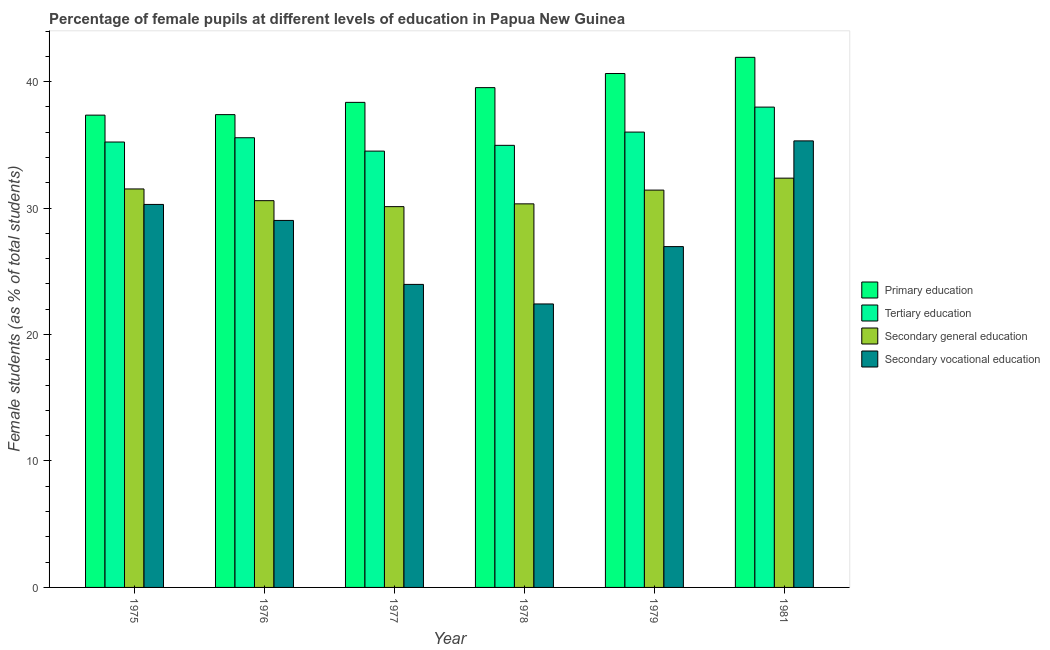How many different coloured bars are there?
Your answer should be very brief. 4. How many groups of bars are there?
Offer a terse response. 6. Are the number of bars per tick equal to the number of legend labels?
Your answer should be very brief. Yes. How many bars are there on the 4th tick from the left?
Offer a very short reply. 4. What is the label of the 1st group of bars from the left?
Give a very brief answer. 1975. In how many cases, is the number of bars for a given year not equal to the number of legend labels?
Your answer should be compact. 0. What is the percentage of female students in secondary vocational education in 1977?
Your response must be concise. 23.97. Across all years, what is the maximum percentage of female students in primary education?
Give a very brief answer. 41.92. Across all years, what is the minimum percentage of female students in primary education?
Ensure brevity in your answer.  37.35. In which year was the percentage of female students in primary education minimum?
Make the answer very short. 1975. What is the total percentage of female students in secondary vocational education in the graph?
Your response must be concise. 167.96. What is the difference between the percentage of female students in secondary vocational education in 1978 and that in 1979?
Give a very brief answer. -4.53. What is the difference between the percentage of female students in tertiary education in 1979 and the percentage of female students in secondary vocational education in 1981?
Your response must be concise. -1.98. What is the average percentage of female students in secondary education per year?
Provide a short and direct response. 31.06. What is the ratio of the percentage of female students in secondary vocational education in 1978 to that in 1981?
Offer a very short reply. 0.63. What is the difference between the highest and the second highest percentage of female students in primary education?
Offer a terse response. 1.28. What is the difference between the highest and the lowest percentage of female students in secondary vocational education?
Your response must be concise. 12.9. In how many years, is the percentage of female students in secondary education greater than the average percentage of female students in secondary education taken over all years?
Your answer should be compact. 3. Is the sum of the percentage of female students in secondary education in 1976 and 1979 greater than the maximum percentage of female students in tertiary education across all years?
Your response must be concise. Yes. What does the 1st bar from the left in 1981 represents?
Offer a terse response. Primary education. What does the 1st bar from the right in 1975 represents?
Make the answer very short. Secondary vocational education. Is it the case that in every year, the sum of the percentage of female students in primary education and percentage of female students in tertiary education is greater than the percentage of female students in secondary education?
Keep it short and to the point. Yes. How many bars are there?
Your answer should be very brief. 24. How many years are there in the graph?
Your answer should be compact. 6. Does the graph contain any zero values?
Give a very brief answer. No. How are the legend labels stacked?
Your response must be concise. Vertical. What is the title of the graph?
Give a very brief answer. Percentage of female pupils at different levels of education in Papua New Guinea. Does "UNPBF" appear as one of the legend labels in the graph?
Give a very brief answer. No. What is the label or title of the Y-axis?
Offer a very short reply. Female students (as % of total students). What is the Female students (as % of total students) of Primary education in 1975?
Your answer should be compact. 37.35. What is the Female students (as % of total students) in Tertiary education in 1975?
Provide a short and direct response. 35.22. What is the Female students (as % of total students) in Secondary general education in 1975?
Ensure brevity in your answer.  31.51. What is the Female students (as % of total students) in Secondary vocational education in 1975?
Keep it short and to the point. 30.29. What is the Female students (as % of total students) in Primary education in 1976?
Your answer should be very brief. 37.39. What is the Female students (as % of total students) of Tertiary education in 1976?
Give a very brief answer. 35.56. What is the Female students (as % of total students) in Secondary general education in 1976?
Your answer should be compact. 30.59. What is the Female students (as % of total students) in Secondary vocational education in 1976?
Your answer should be very brief. 29.02. What is the Female students (as % of total students) in Primary education in 1977?
Ensure brevity in your answer.  38.36. What is the Female students (as % of total students) in Tertiary education in 1977?
Your answer should be compact. 34.51. What is the Female students (as % of total students) in Secondary general education in 1977?
Offer a terse response. 30.11. What is the Female students (as % of total students) of Secondary vocational education in 1977?
Your response must be concise. 23.97. What is the Female students (as % of total students) in Primary education in 1978?
Your response must be concise. 39.53. What is the Female students (as % of total students) in Tertiary education in 1978?
Provide a succinct answer. 34.96. What is the Female students (as % of total students) of Secondary general education in 1978?
Ensure brevity in your answer.  30.33. What is the Female students (as % of total students) in Secondary vocational education in 1978?
Your answer should be compact. 22.42. What is the Female students (as % of total students) of Primary education in 1979?
Ensure brevity in your answer.  40.64. What is the Female students (as % of total students) in Tertiary education in 1979?
Keep it short and to the point. 36.01. What is the Female students (as % of total students) in Secondary general education in 1979?
Your answer should be very brief. 31.42. What is the Female students (as % of total students) in Secondary vocational education in 1979?
Keep it short and to the point. 26.95. What is the Female students (as % of total students) of Primary education in 1981?
Offer a very short reply. 41.92. What is the Female students (as % of total students) of Tertiary education in 1981?
Your answer should be compact. 37.99. What is the Female students (as % of total students) of Secondary general education in 1981?
Your answer should be very brief. 32.37. What is the Female students (as % of total students) of Secondary vocational education in 1981?
Your answer should be very brief. 35.31. Across all years, what is the maximum Female students (as % of total students) in Primary education?
Give a very brief answer. 41.92. Across all years, what is the maximum Female students (as % of total students) in Tertiary education?
Offer a very short reply. 37.99. Across all years, what is the maximum Female students (as % of total students) in Secondary general education?
Ensure brevity in your answer.  32.37. Across all years, what is the maximum Female students (as % of total students) of Secondary vocational education?
Your answer should be very brief. 35.31. Across all years, what is the minimum Female students (as % of total students) in Primary education?
Offer a very short reply. 37.35. Across all years, what is the minimum Female students (as % of total students) in Tertiary education?
Give a very brief answer. 34.51. Across all years, what is the minimum Female students (as % of total students) in Secondary general education?
Offer a very short reply. 30.11. Across all years, what is the minimum Female students (as % of total students) of Secondary vocational education?
Provide a succinct answer. 22.42. What is the total Female students (as % of total students) of Primary education in the graph?
Give a very brief answer. 235.19. What is the total Female students (as % of total students) in Tertiary education in the graph?
Your response must be concise. 214.25. What is the total Female students (as % of total students) of Secondary general education in the graph?
Your answer should be very brief. 186.34. What is the total Female students (as % of total students) of Secondary vocational education in the graph?
Ensure brevity in your answer.  167.96. What is the difference between the Female students (as % of total students) in Primary education in 1975 and that in 1976?
Give a very brief answer. -0.04. What is the difference between the Female students (as % of total students) in Tertiary education in 1975 and that in 1976?
Provide a short and direct response. -0.34. What is the difference between the Female students (as % of total students) of Secondary general education in 1975 and that in 1976?
Your response must be concise. 0.93. What is the difference between the Female students (as % of total students) of Secondary vocational education in 1975 and that in 1976?
Offer a very short reply. 1.27. What is the difference between the Female students (as % of total students) of Primary education in 1975 and that in 1977?
Offer a very short reply. -1.01. What is the difference between the Female students (as % of total students) of Tertiary education in 1975 and that in 1977?
Make the answer very short. 0.72. What is the difference between the Female students (as % of total students) in Secondary general education in 1975 and that in 1977?
Offer a very short reply. 1.4. What is the difference between the Female students (as % of total students) in Secondary vocational education in 1975 and that in 1977?
Provide a short and direct response. 6.32. What is the difference between the Female students (as % of total students) of Primary education in 1975 and that in 1978?
Ensure brevity in your answer.  -2.17. What is the difference between the Female students (as % of total students) of Tertiary education in 1975 and that in 1978?
Provide a short and direct response. 0.26. What is the difference between the Female students (as % of total students) in Secondary general education in 1975 and that in 1978?
Ensure brevity in your answer.  1.18. What is the difference between the Female students (as % of total students) of Secondary vocational education in 1975 and that in 1978?
Your response must be concise. 7.87. What is the difference between the Female students (as % of total students) of Primary education in 1975 and that in 1979?
Ensure brevity in your answer.  -3.29. What is the difference between the Female students (as % of total students) of Tertiary education in 1975 and that in 1979?
Keep it short and to the point. -0.79. What is the difference between the Female students (as % of total students) of Secondary general education in 1975 and that in 1979?
Offer a very short reply. 0.09. What is the difference between the Female students (as % of total students) of Secondary vocational education in 1975 and that in 1979?
Offer a terse response. 3.34. What is the difference between the Female students (as % of total students) of Primary education in 1975 and that in 1981?
Offer a terse response. -4.57. What is the difference between the Female students (as % of total students) of Tertiary education in 1975 and that in 1981?
Ensure brevity in your answer.  -2.76. What is the difference between the Female students (as % of total students) in Secondary general education in 1975 and that in 1981?
Provide a succinct answer. -0.85. What is the difference between the Female students (as % of total students) of Secondary vocational education in 1975 and that in 1981?
Your answer should be very brief. -5.02. What is the difference between the Female students (as % of total students) in Primary education in 1976 and that in 1977?
Give a very brief answer. -0.97. What is the difference between the Female students (as % of total students) of Tertiary education in 1976 and that in 1977?
Offer a terse response. 1.06. What is the difference between the Female students (as % of total students) of Secondary general education in 1976 and that in 1977?
Offer a terse response. 0.47. What is the difference between the Female students (as % of total students) of Secondary vocational education in 1976 and that in 1977?
Ensure brevity in your answer.  5.06. What is the difference between the Female students (as % of total students) of Primary education in 1976 and that in 1978?
Provide a succinct answer. -2.13. What is the difference between the Female students (as % of total students) in Tertiary education in 1976 and that in 1978?
Provide a succinct answer. 0.6. What is the difference between the Female students (as % of total students) in Secondary general education in 1976 and that in 1978?
Ensure brevity in your answer.  0.25. What is the difference between the Female students (as % of total students) of Secondary vocational education in 1976 and that in 1978?
Make the answer very short. 6.6. What is the difference between the Female students (as % of total students) in Primary education in 1976 and that in 1979?
Your answer should be very brief. -3.25. What is the difference between the Female students (as % of total students) in Tertiary education in 1976 and that in 1979?
Keep it short and to the point. -0.45. What is the difference between the Female students (as % of total students) of Secondary general education in 1976 and that in 1979?
Your response must be concise. -0.84. What is the difference between the Female students (as % of total students) in Secondary vocational education in 1976 and that in 1979?
Offer a terse response. 2.07. What is the difference between the Female students (as % of total students) of Primary education in 1976 and that in 1981?
Your answer should be compact. -4.53. What is the difference between the Female students (as % of total students) in Tertiary education in 1976 and that in 1981?
Your answer should be very brief. -2.42. What is the difference between the Female students (as % of total students) in Secondary general education in 1976 and that in 1981?
Offer a very short reply. -1.78. What is the difference between the Female students (as % of total students) in Secondary vocational education in 1976 and that in 1981?
Provide a short and direct response. -6.29. What is the difference between the Female students (as % of total students) in Primary education in 1977 and that in 1978?
Offer a very short reply. -1.17. What is the difference between the Female students (as % of total students) of Tertiary education in 1977 and that in 1978?
Your response must be concise. -0.46. What is the difference between the Female students (as % of total students) in Secondary general education in 1977 and that in 1978?
Offer a very short reply. -0.22. What is the difference between the Female students (as % of total students) of Secondary vocational education in 1977 and that in 1978?
Keep it short and to the point. 1.55. What is the difference between the Female students (as % of total students) in Primary education in 1977 and that in 1979?
Provide a succinct answer. -2.28. What is the difference between the Female students (as % of total students) in Tertiary education in 1977 and that in 1979?
Offer a terse response. -1.5. What is the difference between the Female students (as % of total students) of Secondary general education in 1977 and that in 1979?
Your answer should be very brief. -1.31. What is the difference between the Female students (as % of total students) of Secondary vocational education in 1977 and that in 1979?
Make the answer very short. -2.99. What is the difference between the Female students (as % of total students) in Primary education in 1977 and that in 1981?
Make the answer very short. -3.56. What is the difference between the Female students (as % of total students) in Tertiary education in 1977 and that in 1981?
Provide a short and direct response. -3.48. What is the difference between the Female students (as % of total students) of Secondary general education in 1977 and that in 1981?
Your response must be concise. -2.25. What is the difference between the Female students (as % of total students) in Secondary vocational education in 1977 and that in 1981?
Keep it short and to the point. -11.35. What is the difference between the Female students (as % of total students) in Primary education in 1978 and that in 1979?
Make the answer very short. -1.12. What is the difference between the Female students (as % of total students) of Tertiary education in 1978 and that in 1979?
Give a very brief answer. -1.05. What is the difference between the Female students (as % of total students) of Secondary general education in 1978 and that in 1979?
Make the answer very short. -1.09. What is the difference between the Female students (as % of total students) in Secondary vocational education in 1978 and that in 1979?
Make the answer very short. -4.53. What is the difference between the Female students (as % of total students) in Primary education in 1978 and that in 1981?
Offer a terse response. -2.4. What is the difference between the Female students (as % of total students) in Tertiary education in 1978 and that in 1981?
Your response must be concise. -3.02. What is the difference between the Female students (as % of total students) of Secondary general education in 1978 and that in 1981?
Provide a short and direct response. -2.03. What is the difference between the Female students (as % of total students) in Secondary vocational education in 1978 and that in 1981?
Provide a succinct answer. -12.9. What is the difference between the Female students (as % of total students) in Primary education in 1979 and that in 1981?
Give a very brief answer. -1.28. What is the difference between the Female students (as % of total students) in Tertiary education in 1979 and that in 1981?
Ensure brevity in your answer.  -1.98. What is the difference between the Female students (as % of total students) in Secondary general education in 1979 and that in 1981?
Provide a succinct answer. -0.95. What is the difference between the Female students (as % of total students) of Secondary vocational education in 1979 and that in 1981?
Give a very brief answer. -8.36. What is the difference between the Female students (as % of total students) in Primary education in 1975 and the Female students (as % of total students) in Tertiary education in 1976?
Make the answer very short. 1.79. What is the difference between the Female students (as % of total students) of Primary education in 1975 and the Female students (as % of total students) of Secondary general education in 1976?
Your answer should be very brief. 6.76. What is the difference between the Female students (as % of total students) of Primary education in 1975 and the Female students (as % of total students) of Secondary vocational education in 1976?
Your answer should be very brief. 8.33. What is the difference between the Female students (as % of total students) of Tertiary education in 1975 and the Female students (as % of total students) of Secondary general education in 1976?
Offer a very short reply. 4.64. What is the difference between the Female students (as % of total students) of Tertiary education in 1975 and the Female students (as % of total students) of Secondary vocational education in 1976?
Your answer should be very brief. 6.2. What is the difference between the Female students (as % of total students) in Secondary general education in 1975 and the Female students (as % of total students) in Secondary vocational education in 1976?
Offer a very short reply. 2.49. What is the difference between the Female students (as % of total students) of Primary education in 1975 and the Female students (as % of total students) of Tertiary education in 1977?
Ensure brevity in your answer.  2.84. What is the difference between the Female students (as % of total students) in Primary education in 1975 and the Female students (as % of total students) in Secondary general education in 1977?
Your response must be concise. 7.24. What is the difference between the Female students (as % of total students) of Primary education in 1975 and the Female students (as % of total students) of Secondary vocational education in 1977?
Provide a short and direct response. 13.39. What is the difference between the Female students (as % of total students) of Tertiary education in 1975 and the Female students (as % of total students) of Secondary general education in 1977?
Provide a short and direct response. 5.11. What is the difference between the Female students (as % of total students) of Tertiary education in 1975 and the Female students (as % of total students) of Secondary vocational education in 1977?
Provide a short and direct response. 11.26. What is the difference between the Female students (as % of total students) in Secondary general education in 1975 and the Female students (as % of total students) in Secondary vocational education in 1977?
Give a very brief answer. 7.55. What is the difference between the Female students (as % of total students) in Primary education in 1975 and the Female students (as % of total students) in Tertiary education in 1978?
Your answer should be very brief. 2.39. What is the difference between the Female students (as % of total students) in Primary education in 1975 and the Female students (as % of total students) in Secondary general education in 1978?
Your response must be concise. 7.02. What is the difference between the Female students (as % of total students) of Primary education in 1975 and the Female students (as % of total students) of Secondary vocational education in 1978?
Offer a very short reply. 14.93. What is the difference between the Female students (as % of total students) of Tertiary education in 1975 and the Female students (as % of total students) of Secondary general education in 1978?
Your answer should be very brief. 4.89. What is the difference between the Female students (as % of total students) of Tertiary education in 1975 and the Female students (as % of total students) of Secondary vocational education in 1978?
Your answer should be very brief. 12.81. What is the difference between the Female students (as % of total students) in Secondary general education in 1975 and the Female students (as % of total students) in Secondary vocational education in 1978?
Provide a succinct answer. 9.1. What is the difference between the Female students (as % of total students) of Primary education in 1975 and the Female students (as % of total students) of Tertiary education in 1979?
Provide a succinct answer. 1.34. What is the difference between the Female students (as % of total students) of Primary education in 1975 and the Female students (as % of total students) of Secondary general education in 1979?
Provide a short and direct response. 5.93. What is the difference between the Female students (as % of total students) of Primary education in 1975 and the Female students (as % of total students) of Secondary vocational education in 1979?
Ensure brevity in your answer.  10.4. What is the difference between the Female students (as % of total students) in Tertiary education in 1975 and the Female students (as % of total students) in Secondary general education in 1979?
Keep it short and to the point. 3.8. What is the difference between the Female students (as % of total students) in Tertiary education in 1975 and the Female students (as % of total students) in Secondary vocational education in 1979?
Provide a succinct answer. 8.27. What is the difference between the Female students (as % of total students) in Secondary general education in 1975 and the Female students (as % of total students) in Secondary vocational education in 1979?
Your answer should be compact. 4.56. What is the difference between the Female students (as % of total students) in Primary education in 1975 and the Female students (as % of total students) in Tertiary education in 1981?
Give a very brief answer. -0.64. What is the difference between the Female students (as % of total students) of Primary education in 1975 and the Female students (as % of total students) of Secondary general education in 1981?
Provide a succinct answer. 4.98. What is the difference between the Female students (as % of total students) in Primary education in 1975 and the Female students (as % of total students) in Secondary vocational education in 1981?
Keep it short and to the point. 2.04. What is the difference between the Female students (as % of total students) in Tertiary education in 1975 and the Female students (as % of total students) in Secondary general education in 1981?
Your answer should be compact. 2.86. What is the difference between the Female students (as % of total students) in Tertiary education in 1975 and the Female students (as % of total students) in Secondary vocational education in 1981?
Give a very brief answer. -0.09. What is the difference between the Female students (as % of total students) of Secondary general education in 1975 and the Female students (as % of total students) of Secondary vocational education in 1981?
Your response must be concise. -3.8. What is the difference between the Female students (as % of total students) in Primary education in 1976 and the Female students (as % of total students) in Tertiary education in 1977?
Offer a very short reply. 2.88. What is the difference between the Female students (as % of total students) of Primary education in 1976 and the Female students (as % of total students) of Secondary general education in 1977?
Keep it short and to the point. 7.28. What is the difference between the Female students (as % of total students) in Primary education in 1976 and the Female students (as % of total students) in Secondary vocational education in 1977?
Offer a very short reply. 13.43. What is the difference between the Female students (as % of total students) of Tertiary education in 1976 and the Female students (as % of total students) of Secondary general education in 1977?
Provide a succinct answer. 5.45. What is the difference between the Female students (as % of total students) in Tertiary education in 1976 and the Female students (as % of total students) in Secondary vocational education in 1977?
Keep it short and to the point. 11.6. What is the difference between the Female students (as % of total students) of Secondary general education in 1976 and the Female students (as % of total students) of Secondary vocational education in 1977?
Keep it short and to the point. 6.62. What is the difference between the Female students (as % of total students) in Primary education in 1976 and the Female students (as % of total students) in Tertiary education in 1978?
Offer a terse response. 2.43. What is the difference between the Female students (as % of total students) in Primary education in 1976 and the Female students (as % of total students) in Secondary general education in 1978?
Offer a terse response. 7.06. What is the difference between the Female students (as % of total students) of Primary education in 1976 and the Female students (as % of total students) of Secondary vocational education in 1978?
Make the answer very short. 14.97. What is the difference between the Female students (as % of total students) in Tertiary education in 1976 and the Female students (as % of total students) in Secondary general education in 1978?
Make the answer very short. 5.23. What is the difference between the Female students (as % of total students) of Tertiary education in 1976 and the Female students (as % of total students) of Secondary vocational education in 1978?
Give a very brief answer. 13.14. What is the difference between the Female students (as % of total students) in Secondary general education in 1976 and the Female students (as % of total students) in Secondary vocational education in 1978?
Ensure brevity in your answer.  8.17. What is the difference between the Female students (as % of total students) of Primary education in 1976 and the Female students (as % of total students) of Tertiary education in 1979?
Provide a short and direct response. 1.38. What is the difference between the Female students (as % of total students) of Primary education in 1976 and the Female students (as % of total students) of Secondary general education in 1979?
Your answer should be very brief. 5.97. What is the difference between the Female students (as % of total students) of Primary education in 1976 and the Female students (as % of total students) of Secondary vocational education in 1979?
Your answer should be compact. 10.44. What is the difference between the Female students (as % of total students) in Tertiary education in 1976 and the Female students (as % of total students) in Secondary general education in 1979?
Give a very brief answer. 4.14. What is the difference between the Female students (as % of total students) in Tertiary education in 1976 and the Female students (as % of total students) in Secondary vocational education in 1979?
Give a very brief answer. 8.61. What is the difference between the Female students (as % of total students) in Secondary general education in 1976 and the Female students (as % of total students) in Secondary vocational education in 1979?
Make the answer very short. 3.63. What is the difference between the Female students (as % of total students) in Primary education in 1976 and the Female students (as % of total students) in Tertiary education in 1981?
Offer a terse response. -0.6. What is the difference between the Female students (as % of total students) of Primary education in 1976 and the Female students (as % of total students) of Secondary general education in 1981?
Offer a very short reply. 5.02. What is the difference between the Female students (as % of total students) in Primary education in 1976 and the Female students (as % of total students) in Secondary vocational education in 1981?
Your response must be concise. 2.08. What is the difference between the Female students (as % of total students) of Tertiary education in 1976 and the Female students (as % of total students) of Secondary general education in 1981?
Keep it short and to the point. 3.2. What is the difference between the Female students (as % of total students) in Tertiary education in 1976 and the Female students (as % of total students) in Secondary vocational education in 1981?
Offer a very short reply. 0.25. What is the difference between the Female students (as % of total students) of Secondary general education in 1976 and the Female students (as % of total students) of Secondary vocational education in 1981?
Make the answer very short. -4.73. What is the difference between the Female students (as % of total students) of Primary education in 1977 and the Female students (as % of total students) of Tertiary education in 1978?
Offer a terse response. 3.4. What is the difference between the Female students (as % of total students) in Primary education in 1977 and the Female students (as % of total students) in Secondary general education in 1978?
Your answer should be very brief. 8.03. What is the difference between the Female students (as % of total students) in Primary education in 1977 and the Female students (as % of total students) in Secondary vocational education in 1978?
Offer a very short reply. 15.94. What is the difference between the Female students (as % of total students) of Tertiary education in 1977 and the Female students (as % of total students) of Secondary general education in 1978?
Your response must be concise. 4.17. What is the difference between the Female students (as % of total students) in Tertiary education in 1977 and the Female students (as % of total students) in Secondary vocational education in 1978?
Your response must be concise. 12.09. What is the difference between the Female students (as % of total students) in Secondary general education in 1977 and the Female students (as % of total students) in Secondary vocational education in 1978?
Offer a very short reply. 7.7. What is the difference between the Female students (as % of total students) in Primary education in 1977 and the Female students (as % of total students) in Tertiary education in 1979?
Offer a very short reply. 2.35. What is the difference between the Female students (as % of total students) in Primary education in 1977 and the Female students (as % of total students) in Secondary general education in 1979?
Your answer should be very brief. 6.94. What is the difference between the Female students (as % of total students) in Primary education in 1977 and the Female students (as % of total students) in Secondary vocational education in 1979?
Provide a short and direct response. 11.41. What is the difference between the Female students (as % of total students) of Tertiary education in 1977 and the Female students (as % of total students) of Secondary general education in 1979?
Offer a terse response. 3.08. What is the difference between the Female students (as % of total students) in Tertiary education in 1977 and the Female students (as % of total students) in Secondary vocational education in 1979?
Offer a terse response. 7.55. What is the difference between the Female students (as % of total students) in Secondary general education in 1977 and the Female students (as % of total students) in Secondary vocational education in 1979?
Your response must be concise. 3.16. What is the difference between the Female students (as % of total students) in Primary education in 1977 and the Female students (as % of total students) in Tertiary education in 1981?
Provide a succinct answer. 0.37. What is the difference between the Female students (as % of total students) in Primary education in 1977 and the Female students (as % of total students) in Secondary general education in 1981?
Keep it short and to the point. 5.99. What is the difference between the Female students (as % of total students) of Primary education in 1977 and the Female students (as % of total students) of Secondary vocational education in 1981?
Your answer should be compact. 3.05. What is the difference between the Female students (as % of total students) of Tertiary education in 1977 and the Female students (as % of total students) of Secondary general education in 1981?
Give a very brief answer. 2.14. What is the difference between the Female students (as % of total students) of Tertiary education in 1977 and the Female students (as % of total students) of Secondary vocational education in 1981?
Your answer should be compact. -0.81. What is the difference between the Female students (as % of total students) of Secondary general education in 1977 and the Female students (as % of total students) of Secondary vocational education in 1981?
Keep it short and to the point. -5.2. What is the difference between the Female students (as % of total students) in Primary education in 1978 and the Female students (as % of total students) in Tertiary education in 1979?
Make the answer very short. 3.52. What is the difference between the Female students (as % of total students) of Primary education in 1978 and the Female students (as % of total students) of Secondary general education in 1979?
Provide a short and direct response. 8.1. What is the difference between the Female students (as % of total students) in Primary education in 1978 and the Female students (as % of total students) in Secondary vocational education in 1979?
Make the answer very short. 12.57. What is the difference between the Female students (as % of total students) in Tertiary education in 1978 and the Female students (as % of total students) in Secondary general education in 1979?
Keep it short and to the point. 3.54. What is the difference between the Female students (as % of total students) of Tertiary education in 1978 and the Female students (as % of total students) of Secondary vocational education in 1979?
Offer a very short reply. 8.01. What is the difference between the Female students (as % of total students) in Secondary general education in 1978 and the Female students (as % of total students) in Secondary vocational education in 1979?
Ensure brevity in your answer.  3.38. What is the difference between the Female students (as % of total students) of Primary education in 1978 and the Female students (as % of total students) of Tertiary education in 1981?
Ensure brevity in your answer.  1.54. What is the difference between the Female students (as % of total students) in Primary education in 1978 and the Female students (as % of total students) in Secondary general education in 1981?
Provide a succinct answer. 7.16. What is the difference between the Female students (as % of total students) in Primary education in 1978 and the Female students (as % of total students) in Secondary vocational education in 1981?
Provide a short and direct response. 4.21. What is the difference between the Female students (as % of total students) in Tertiary education in 1978 and the Female students (as % of total students) in Secondary general education in 1981?
Provide a succinct answer. 2.59. What is the difference between the Female students (as % of total students) of Tertiary education in 1978 and the Female students (as % of total students) of Secondary vocational education in 1981?
Your response must be concise. -0.35. What is the difference between the Female students (as % of total students) of Secondary general education in 1978 and the Female students (as % of total students) of Secondary vocational education in 1981?
Your answer should be very brief. -4.98. What is the difference between the Female students (as % of total students) in Primary education in 1979 and the Female students (as % of total students) in Tertiary education in 1981?
Offer a very short reply. 2.66. What is the difference between the Female students (as % of total students) of Primary education in 1979 and the Female students (as % of total students) of Secondary general education in 1981?
Make the answer very short. 8.27. What is the difference between the Female students (as % of total students) in Primary education in 1979 and the Female students (as % of total students) in Secondary vocational education in 1981?
Provide a short and direct response. 5.33. What is the difference between the Female students (as % of total students) in Tertiary education in 1979 and the Female students (as % of total students) in Secondary general education in 1981?
Offer a terse response. 3.64. What is the difference between the Female students (as % of total students) of Tertiary education in 1979 and the Female students (as % of total students) of Secondary vocational education in 1981?
Make the answer very short. 0.7. What is the difference between the Female students (as % of total students) in Secondary general education in 1979 and the Female students (as % of total students) in Secondary vocational education in 1981?
Make the answer very short. -3.89. What is the average Female students (as % of total students) in Primary education per year?
Offer a terse response. 39.2. What is the average Female students (as % of total students) of Tertiary education per year?
Make the answer very short. 35.71. What is the average Female students (as % of total students) in Secondary general education per year?
Ensure brevity in your answer.  31.06. What is the average Female students (as % of total students) in Secondary vocational education per year?
Your response must be concise. 27.99. In the year 1975, what is the difference between the Female students (as % of total students) of Primary education and Female students (as % of total students) of Tertiary education?
Give a very brief answer. 2.13. In the year 1975, what is the difference between the Female students (as % of total students) of Primary education and Female students (as % of total students) of Secondary general education?
Your answer should be very brief. 5.84. In the year 1975, what is the difference between the Female students (as % of total students) in Primary education and Female students (as % of total students) in Secondary vocational education?
Give a very brief answer. 7.06. In the year 1975, what is the difference between the Female students (as % of total students) in Tertiary education and Female students (as % of total students) in Secondary general education?
Make the answer very short. 3.71. In the year 1975, what is the difference between the Female students (as % of total students) of Tertiary education and Female students (as % of total students) of Secondary vocational education?
Give a very brief answer. 4.94. In the year 1975, what is the difference between the Female students (as % of total students) in Secondary general education and Female students (as % of total students) in Secondary vocational education?
Ensure brevity in your answer.  1.22. In the year 1976, what is the difference between the Female students (as % of total students) in Primary education and Female students (as % of total students) in Tertiary education?
Keep it short and to the point. 1.83. In the year 1976, what is the difference between the Female students (as % of total students) of Primary education and Female students (as % of total students) of Secondary general education?
Keep it short and to the point. 6.8. In the year 1976, what is the difference between the Female students (as % of total students) of Primary education and Female students (as % of total students) of Secondary vocational education?
Offer a very short reply. 8.37. In the year 1976, what is the difference between the Female students (as % of total students) in Tertiary education and Female students (as % of total students) in Secondary general education?
Make the answer very short. 4.98. In the year 1976, what is the difference between the Female students (as % of total students) in Tertiary education and Female students (as % of total students) in Secondary vocational education?
Keep it short and to the point. 6.54. In the year 1976, what is the difference between the Female students (as % of total students) of Secondary general education and Female students (as % of total students) of Secondary vocational education?
Offer a very short reply. 1.56. In the year 1977, what is the difference between the Female students (as % of total students) of Primary education and Female students (as % of total students) of Tertiary education?
Keep it short and to the point. 3.85. In the year 1977, what is the difference between the Female students (as % of total students) of Primary education and Female students (as % of total students) of Secondary general education?
Offer a very short reply. 8.25. In the year 1977, what is the difference between the Female students (as % of total students) of Primary education and Female students (as % of total students) of Secondary vocational education?
Offer a terse response. 14.4. In the year 1977, what is the difference between the Female students (as % of total students) of Tertiary education and Female students (as % of total students) of Secondary general education?
Your response must be concise. 4.39. In the year 1977, what is the difference between the Female students (as % of total students) in Tertiary education and Female students (as % of total students) in Secondary vocational education?
Offer a terse response. 10.54. In the year 1977, what is the difference between the Female students (as % of total students) of Secondary general education and Female students (as % of total students) of Secondary vocational education?
Ensure brevity in your answer.  6.15. In the year 1978, what is the difference between the Female students (as % of total students) in Primary education and Female students (as % of total students) in Tertiary education?
Ensure brevity in your answer.  4.56. In the year 1978, what is the difference between the Female students (as % of total students) of Primary education and Female students (as % of total students) of Secondary general education?
Offer a very short reply. 9.19. In the year 1978, what is the difference between the Female students (as % of total students) of Primary education and Female students (as % of total students) of Secondary vocational education?
Provide a succinct answer. 17.11. In the year 1978, what is the difference between the Female students (as % of total students) in Tertiary education and Female students (as % of total students) in Secondary general education?
Your answer should be compact. 4.63. In the year 1978, what is the difference between the Female students (as % of total students) in Tertiary education and Female students (as % of total students) in Secondary vocational education?
Give a very brief answer. 12.54. In the year 1978, what is the difference between the Female students (as % of total students) in Secondary general education and Female students (as % of total students) in Secondary vocational education?
Your answer should be very brief. 7.92. In the year 1979, what is the difference between the Female students (as % of total students) of Primary education and Female students (as % of total students) of Tertiary education?
Provide a succinct answer. 4.63. In the year 1979, what is the difference between the Female students (as % of total students) of Primary education and Female students (as % of total students) of Secondary general education?
Keep it short and to the point. 9.22. In the year 1979, what is the difference between the Female students (as % of total students) in Primary education and Female students (as % of total students) in Secondary vocational education?
Provide a succinct answer. 13.69. In the year 1979, what is the difference between the Female students (as % of total students) in Tertiary education and Female students (as % of total students) in Secondary general education?
Give a very brief answer. 4.59. In the year 1979, what is the difference between the Female students (as % of total students) in Tertiary education and Female students (as % of total students) in Secondary vocational education?
Offer a terse response. 9.06. In the year 1979, what is the difference between the Female students (as % of total students) in Secondary general education and Female students (as % of total students) in Secondary vocational education?
Your answer should be very brief. 4.47. In the year 1981, what is the difference between the Female students (as % of total students) of Primary education and Female students (as % of total students) of Tertiary education?
Make the answer very short. 3.94. In the year 1981, what is the difference between the Female students (as % of total students) of Primary education and Female students (as % of total students) of Secondary general education?
Offer a terse response. 9.55. In the year 1981, what is the difference between the Female students (as % of total students) in Primary education and Female students (as % of total students) in Secondary vocational education?
Offer a terse response. 6.61. In the year 1981, what is the difference between the Female students (as % of total students) of Tertiary education and Female students (as % of total students) of Secondary general education?
Keep it short and to the point. 5.62. In the year 1981, what is the difference between the Female students (as % of total students) in Tertiary education and Female students (as % of total students) in Secondary vocational education?
Offer a terse response. 2.67. In the year 1981, what is the difference between the Female students (as % of total students) in Secondary general education and Female students (as % of total students) in Secondary vocational education?
Make the answer very short. -2.95. What is the ratio of the Female students (as % of total students) in Secondary general education in 1975 to that in 1976?
Your response must be concise. 1.03. What is the ratio of the Female students (as % of total students) in Secondary vocational education in 1975 to that in 1976?
Offer a very short reply. 1.04. What is the ratio of the Female students (as % of total students) in Primary education in 1975 to that in 1977?
Your answer should be compact. 0.97. What is the ratio of the Female students (as % of total students) in Tertiary education in 1975 to that in 1977?
Offer a terse response. 1.02. What is the ratio of the Female students (as % of total students) in Secondary general education in 1975 to that in 1977?
Your answer should be compact. 1.05. What is the ratio of the Female students (as % of total students) of Secondary vocational education in 1975 to that in 1977?
Give a very brief answer. 1.26. What is the ratio of the Female students (as % of total students) in Primary education in 1975 to that in 1978?
Offer a very short reply. 0.94. What is the ratio of the Female students (as % of total students) of Tertiary education in 1975 to that in 1978?
Your answer should be compact. 1.01. What is the ratio of the Female students (as % of total students) in Secondary general education in 1975 to that in 1978?
Your answer should be very brief. 1.04. What is the ratio of the Female students (as % of total students) in Secondary vocational education in 1975 to that in 1978?
Ensure brevity in your answer.  1.35. What is the ratio of the Female students (as % of total students) in Primary education in 1975 to that in 1979?
Make the answer very short. 0.92. What is the ratio of the Female students (as % of total students) in Tertiary education in 1975 to that in 1979?
Provide a short and direct response. 0.98. What is the ratio of the Female students (as % of total students) of Secondary general education in 1975 to that in 1979?
Make the answer very short. 1. What is the ratio of the Female students (as % of total students) of Secondary vocational education in 1975 to that in 1979?
Offer a very short reply. 1.12. What is the ratio of the Female students (as % of total students) in Primary education in 1975 to that in 1981?
Ensure brevity in your answer.  0.89. What is the ratio of the Female students (as % of total students) of Tertiary education in 1975 to that in 1981?
Your response must be concise. 0.93. What is the ratio of the Female students (as % of total students) in Secondary general education in 1975 to that in 1981?
Your answer should be compact. 0.97. What is the ratio of the Female students (as % of total students) of Secondary vocational education in 1975 to that in 1981?
Give a very brief answer. 0.86. What is the ratio of the Female students (as % of total students) of Primary education in 1976 to that in 1977?
Your response must be concise. 0.97. What is the ratio of the Female students (as % of total students) in Tertiary education in 1976 to that in 1977?
Keep it short and to the point. 1.03. What is the ratio of the Female students (as % of total students) of Secondary general education in 1976 to that in 1977?
Your answer should be compact. 1.02. What is the ratio of the Female students (as % of total students) of Secondary vocational education in 1976 to that in 1977?
Offer a very short reply. 1.21. What is the ratio of the Female students (as % of total students) of Primary education in 1976 to that in 1978?
Offer a very short reply. 0.95. What is the ratio of the Female students (as % of total students) of Tertiary education in 1976 to that in 1978?
Give a very brief answer. 1.02. What is the ratio of the Female students (as % of total students) of Secondary general education in 1976 to that in 1978?
Your response must be concise. 1.01. What is the ratio of the Female students (as % of total students) of Secondary vocational education in 1976 to that in 1978?
Ensure brevity in your answer.  1.29. What is the ratio of the Female students (as % of total students) in Tertiary education in 1976 to that in 1979?
Make the answer very short. 0.99. What is the ratio of the Female students (as % of total students) in Secondary general education in 1976 to that in 1979?
Provide a short and direct response. 0.97. What is the ratio of the Female students (as % of total students) of Secondary vocational education in 1976 to that in 1979?
Ensure brevity in your answer.  1.08. What is the ratio of the Female students (as % of total students) in Primary education in 1976 to that in 1981?
Ensure brevity in your answer.  0.89. What is the ratio of the Female students (as % of total students) of Tertiary education in 1976 to that in 1981?
Provide a short and direct response. 0.94. What is the ratio of the Female students (as % of total students) of Secondary general education in 1976 to that in 1981?
Your response must be concise. 0.94. What is the ratio of the Female students (as % of total students) of Secondary vocational education in 1976 to that in 1981?
Ensure brevity in your answer.  0.82. What is the ratio of the Female students (as % of total students) in Primary education in 1977 to that in 1978?
Give a very brief answer. 0.97. What is the ratio of the Female students (as % of total students) in Secondary general education in 1977 to that in 1978?
Your answer should be compact. 0.99. What is the ratio of the Female students (as % of total students) of Secondary vocational education in 1977 to that in 1978?
Give a very brief answer. 1.07. What is the ratio of the Female students (as % of total students) of Primary education in 1977 to that in 1979?
Give a very brief answer. 0.94. What is the ratio of the Female students (as % of total students) of Tertiary education in 1977 to that in 1979?
Provide a succinct answer. 0.96. What is the ratio of the Female students (as % of total students) in Secondary general education in 1977 to that in 1979?
Keep it short and to the point. 0.96. What is the ratio of the Female students (as % of total students) of Secondary vocational education in 1977 to that in 1979?
Provide a short and direct response. 0.89. What is the ratio of the Female students (as % of total students) of Primary education in 1977 to that in 1981?
Make the answer very short. 0.92. What is the ratio of the Female students (as % of total students) in Tertiary education in 1977 to that in 1981?
Offer a very short reply. 0.91. What is the ratio of the Female students (as % of total students) of Secondary general education in 1977 to that in 1981?
Your answer should be compact. 0.93. What is the ratio of the Female students (as % of total students) in Secondary vocational education in 1977 to that in 1981?
Provide a succinct answer. 0.68. What is the ratio of the Female students (as % of total students) in Primary education in 1978 to that in 1979?
Your response must be concise. 0.97. What is the ratio of the Female students (as % of total students) of Tertiary education in 1978 to that in 1979?
Provide a short and direct response. 0.97. What is the ratio of the Female students (as % of total students) of Secondary general education in 1978 to that in 1979?
Provide a short and direct response. 0.97. What is the ratio of the Female students (as % of total students) in Secondary vocational education in 1978 to that in 1979?
Your answer should be very brief. 0.83. What is the ratio of the Female students (as % of total students) in Primary education in 1978 to that in 1981?
Your answer should be compact. 0.94. What is the ratio of the Female students (as % of total students) in Tertiary education in 1978 to that in 1981?
Make the answer very short. 0.92. What is the ratio of the Female students (as % of total students) in Secondary general education in 1978 to that in 1981?
Make the answer very short. 0.94. What is the ratio of the Female students (as % of total students) in Secondary vocational education in 1978 to that in 1981?
Ensure brevity in your answer.  0.63. What is the ratio of the Female students (as % of total students) of Primary education in 1979 to that in 1981?
Your answer should be compact. 0.97. What is the ratio of the Female students (as % of total students) of Tertiary education in 1979 to that in 1981?
Offer a terse response. 0.95. What is the ratio of the Female students (as % of total students) of Secondary general education in 1979 to that in 1981?
Your response must be concise. 0.97. What is the ratio of the Female students (as % of total students) in Secondary vocational education in 1979 to that in 1981?
Your answer should be very brief. 0.76. What is the difference between the highest and the second highest Female students (as % of total students) in Primary education?
Offer a terse response. 1.28. What is the difference between the highest and the second highest Female students (as % of total students) of Tertiary education?
Ensure brevity in your answer.  1.98. What is the difference between the highest and the second highest Female students (as % of total students) in Secondary general education?
Offer a very short reply. 0.85. What is the difference between the highest and the second highest Female students (as % of total students) of Secondary vocational education?
Your answer should be very brief. 5.02. What is the difference between the highest and the lowest Female students (as % of total students) of Primary education?
Your answer should be compact. 4.57. What is the difference between the highest and the lowest Female students (as % of total students) of Tertiary education?
Offer a terse response. 3.48. What is the difference between the highest and the lowest Female students (as % of total students) of Secondary general education?
Provide a succinct answer. 2.25. What is the difference between the highest and the lowest Female students (as % of total students) in Secondary vocational education?
Offer a terse response. 12.9. 